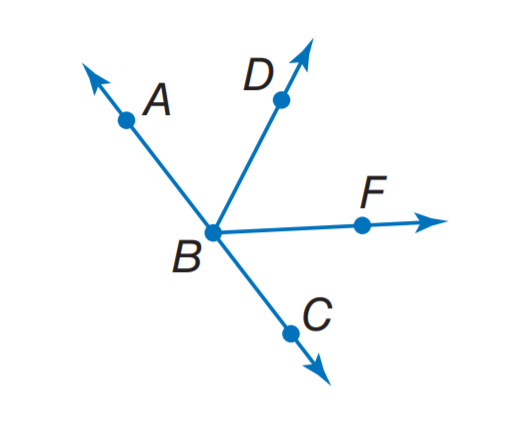Answer the mathemtical geometry problem and directly provide the correct option letter.
Question: \overrightarrow B A and \overrightarrow B C are opposite rays and \overrightarrow B D bisects \angle A B F. If m \angle A B F = 3 x - 8 and m \angle A B D = x + 14, find m \angle A B D.
Choices: A: 14 B: 36 C: 50 D: 54 C 